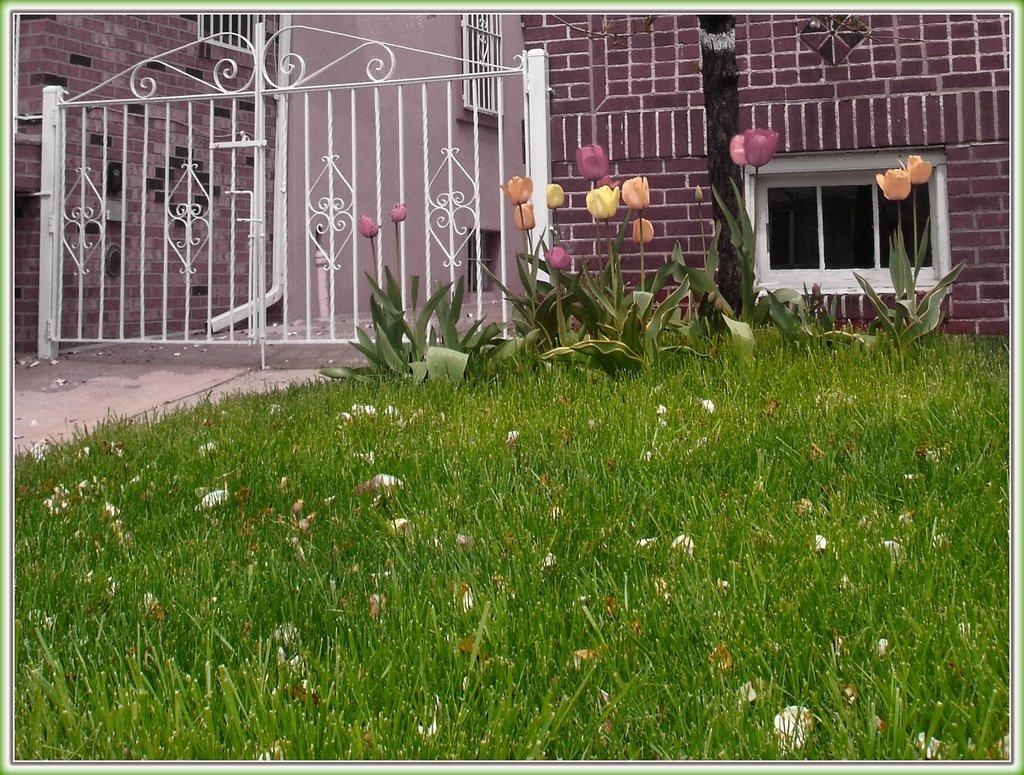What type of vegetation can be seen in the image? There is grass, plants, and flowers in the image. What architectural feature is visible in the image? There is a window, a gate, and walls in the image. What else can be seen in the image besides the vegetation and architectural features? There are objects in the image. How does the board help the water flow in the image? There is no board or water present in the image, so this question cannot be answered. 